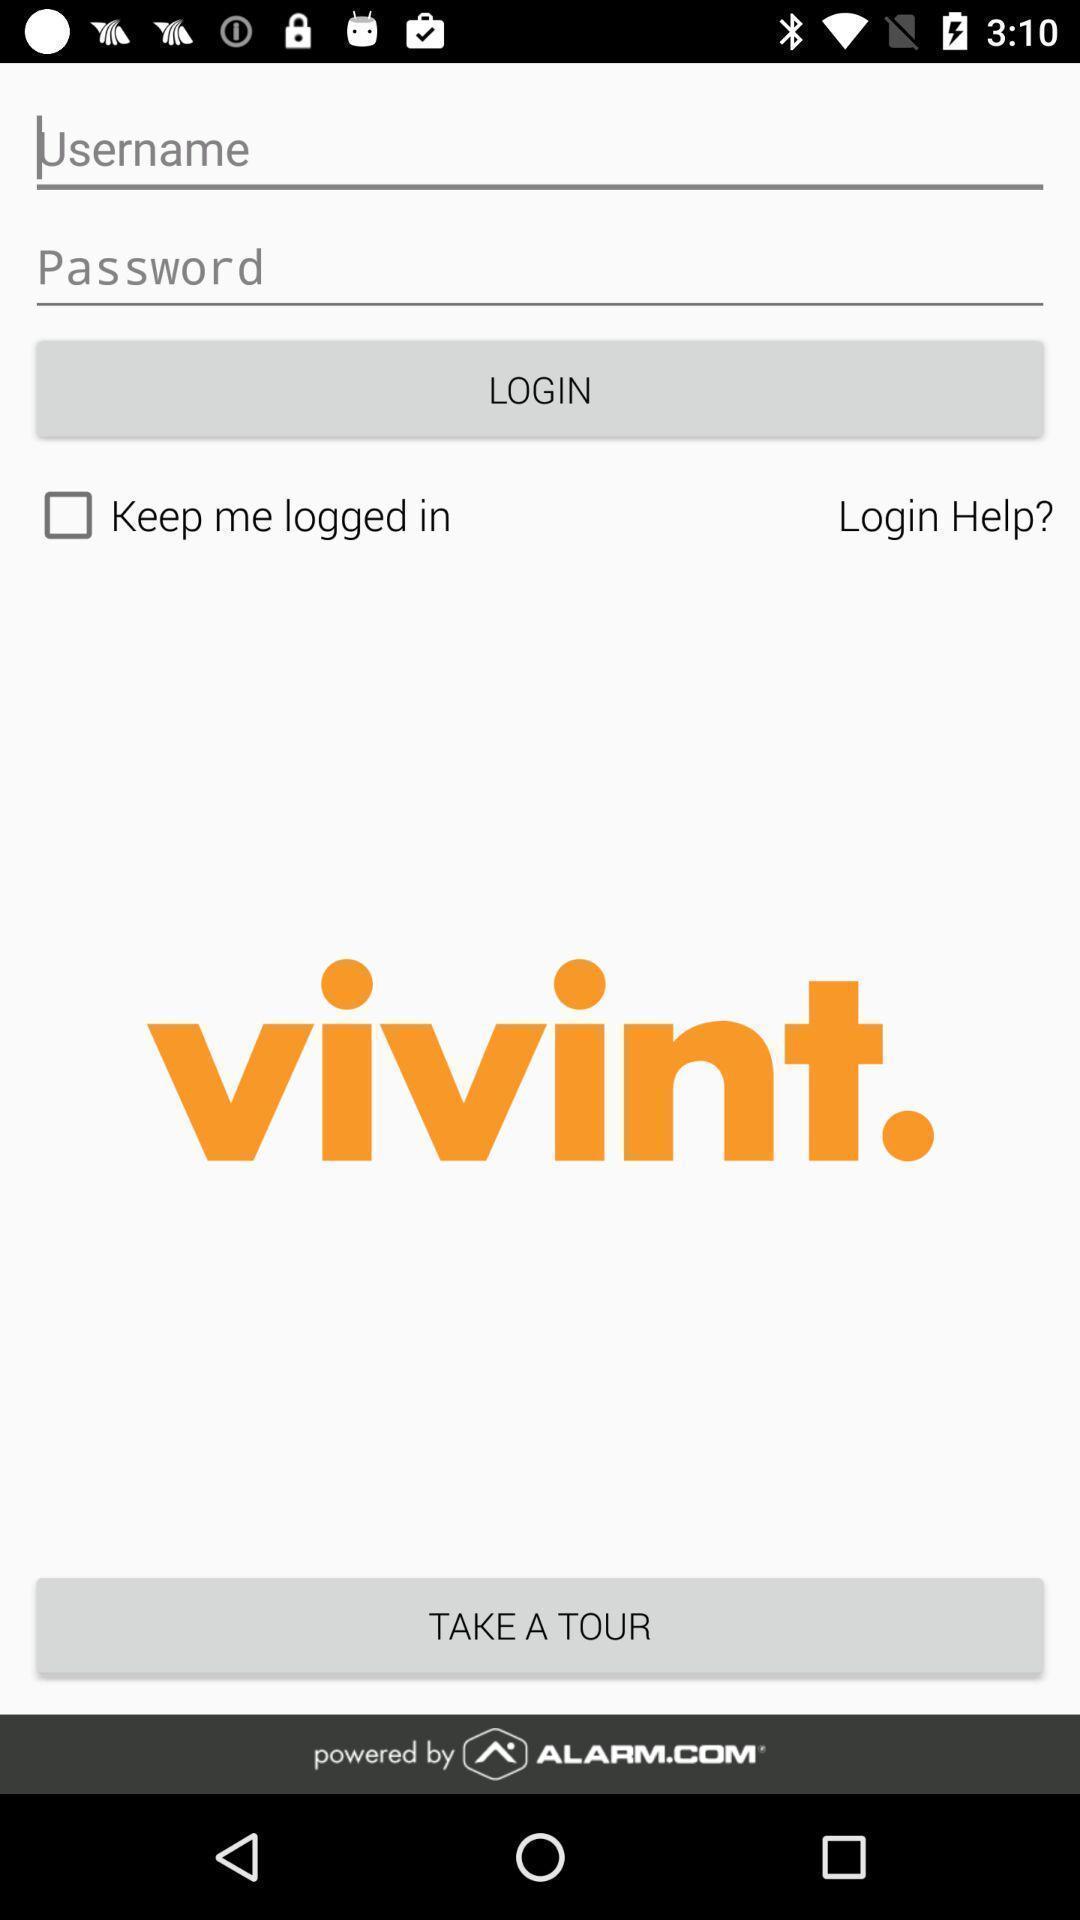What can you discern from this picture? Welcome page. 